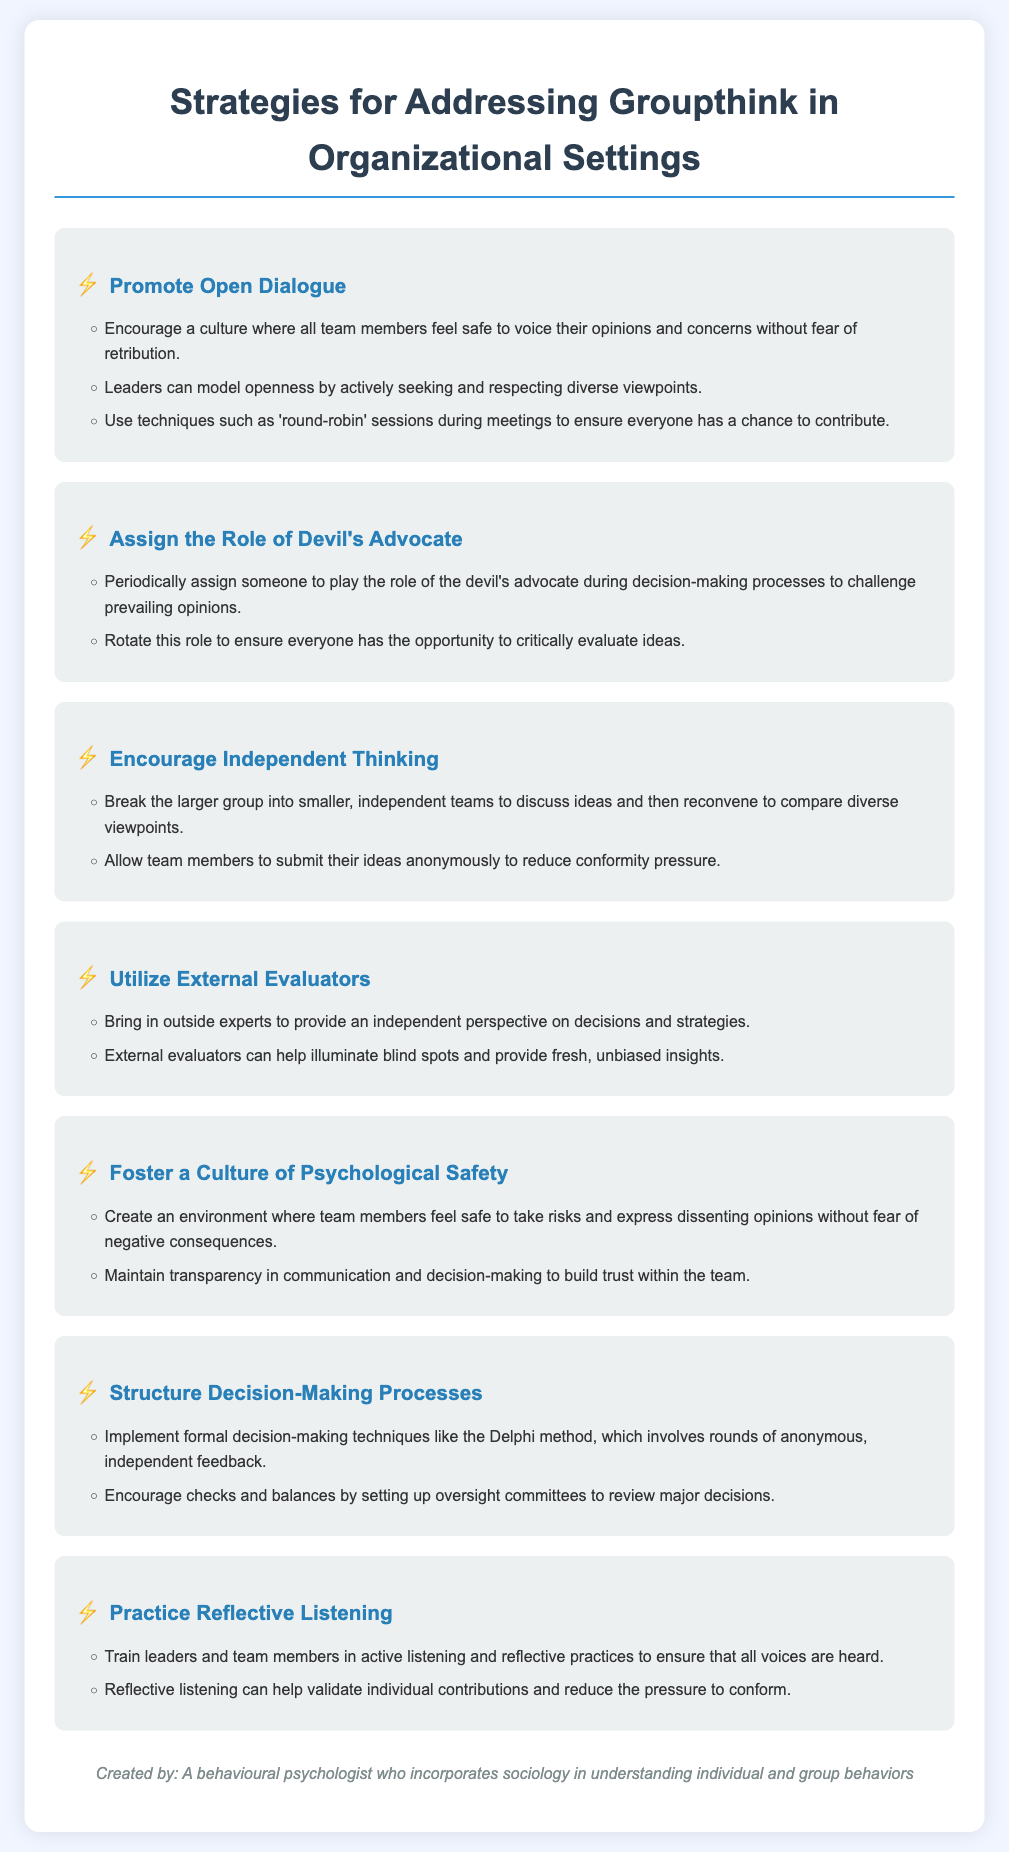What is the main title of the document? The main title is clearly stated at the top of the document, introducing the content focus.
Answer: Strategies for Addressing Groupthink in Organizational Settings How many strategies are listed in the document? The document includes a total count of distinct strategies to tackle groupthink, presented in the infographic structure.
Answer: Seven Which strategy involves bringing in outside experts? This strategy focuses on enhancing decision-making by including perspectives that are not part of the internal group dynamics.
Answer: Utilize External Evaluators What technique is suggested for ensuring all team members can contribute? This technique is emphasized to create an inclusive dialogue by allowing every voice to be heard during discussions.
Answer: Round-robin sessions What role is suggested to be assigned periodically to challenge opinions? This particular role is meant to provoke critical thinking and prevent conformity in decision-making processes.
Answer: Devil's Advocate Which specific decision-making technique is mentioned in the document? The document lists formal techniques aimed at structuring the decision-making process for better outcomes.
Answer: Delphi method What is one key element necessary for fostering a safe environment in teams? This element supports the principle of trust and openness among team members, essential for effective communication and risk-taking.
Answer: Psychological Safety 